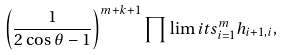<formula> <loc_0><loc_0><loc_500><loc_500>\left ( \frac { 1 } { 2 \cos \theta - 1 } \right ) ^ { m + k + 1 } \prod \lim i t s _ { i = 1 } ^ { m } h _ { i + 1 , i } ,</formula> 